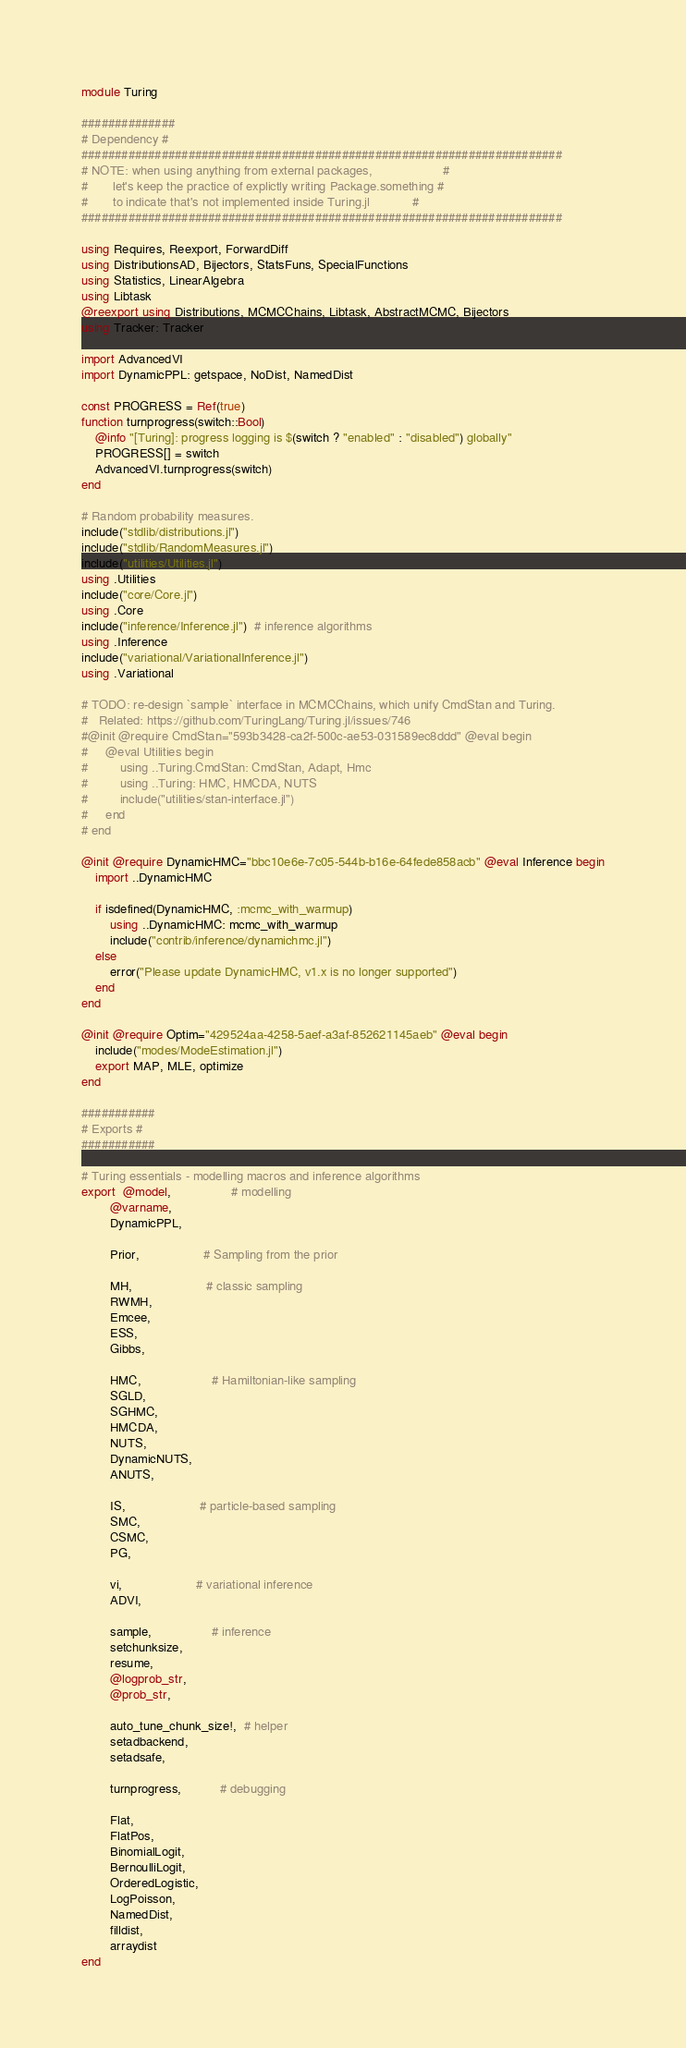Convert code to text. <code><loc_0><loc_0><loc_500><loc_500><_Julia_>module Turing

##############
# Dependency #
########################################################################
# NOTE: when using anything from external packages,                    #
#       let's keep the practice of explictly writing Package.something #
#       to indicate that's not implemented inside Turing.jl            #
########################################################################

using Requires, Reexport, ForwardDiff
using DistributionsAD, Bijectors, StatsFuns, SpecialFunctions
using Statistics, LinearAlgebra
using Libtask
@reexport using Distributions, MCMCChains, Libtask, AbstractMCMC, Bijectors
using Tracker: Tracker

import AdvancedVI
import DynamicPPL: getspace, NoDist, NamedDist

const PROGRESS = Ref(true)
function turnprogress(switch::Bool)
    @info "[Turing]: progress logging is $(switch ? "enabled" : "disabled") globally"
    PROGRESS[] = switch
    AdvancedVI.turnprogress(switch)
end

# Random probability measures.
include("stdlib/distributions.jl")
include("stdlib/RandomMeasures.jl")
include("utilities/Utilities.jl")
using .Utilities
include("core/Core.jl")
using .Core
include("inference/Inference.jl")  # inference algorithms
using .Inference
include("variational/VariationalInference.jl")
using .Variational

# TODO: re-design `sample` interface in MCMCChains, which unify CmdStan and Turing.
#   Related: https://github.com/TuringLang/Turing.jl/issues/746
#@init @require CmdStan="593b3428-ca2f-500c-ae53-031589ec8ddd" @eval begin
#     @eval Utilities begin
#         using ..Turing.CmdStan: CmdStan, Adapt, Hmc
#         using ..Turing: HMC, HMCDA, NUTS
#         include("utilities/stan-interface.jl")
#     end
# end

@init @require DynamicHMC="bbc10e6e-7c05-544b-b16e-64fede858acb" @eval Inference begin
    import ..DynamicHMC

    if isdefined(DynamicHMC, :mcmc_with_warmup)
        using ..DynamicHMC: mcmc_with_warmup
        include("contrib/inference/dynamichmc.jl")
    else
        error("Please update DynamicHMC, v1.x is no longer supported")
    end
end

@init @require Optim="429524aa-4258-5aef-a3af-852621145aeb" @eval begin
    include("modes/ModeEstimation.jl")
    export MAP, MLE, optimize
end

###########
# Exports #
###########

# Turing essentials - modelling macros and inference algorithms
export  @model,                 # modelling
        @varname,
        DynamicPPL,

        Prior,                  # Sampling from the prior

        MH,                     # classic sampling
        RWMH,
        Emcee,
        ESS,
        Gibbs,

        HMC,                    # Hamiltonian-like sampling
        SGLD,
        SGHMC,
        HMCDA,
        NUTS,
        DynamicNUTS,
        ANUTS,

        IS,                     # particle-based sampling
        SMC,
        CSMC,
        PG,

        vi,                     # variational inference
        ADVI,

        sample,                 # inference
        setchunksize,
        resume,
        @logprob_str,
        @prob_str,

        auto_tune_chunk_size!,  # helper
        setadbackend,
        setadsafe,

        turnprogress,           # debugging

        Flat,
        FlatPos,
        BinomialLogit,
        BernoulliLogit,
        OrderedLogistic,
        LogPoisson,
        NamedDist,
        filldist,
        arraydist
end
</code> 